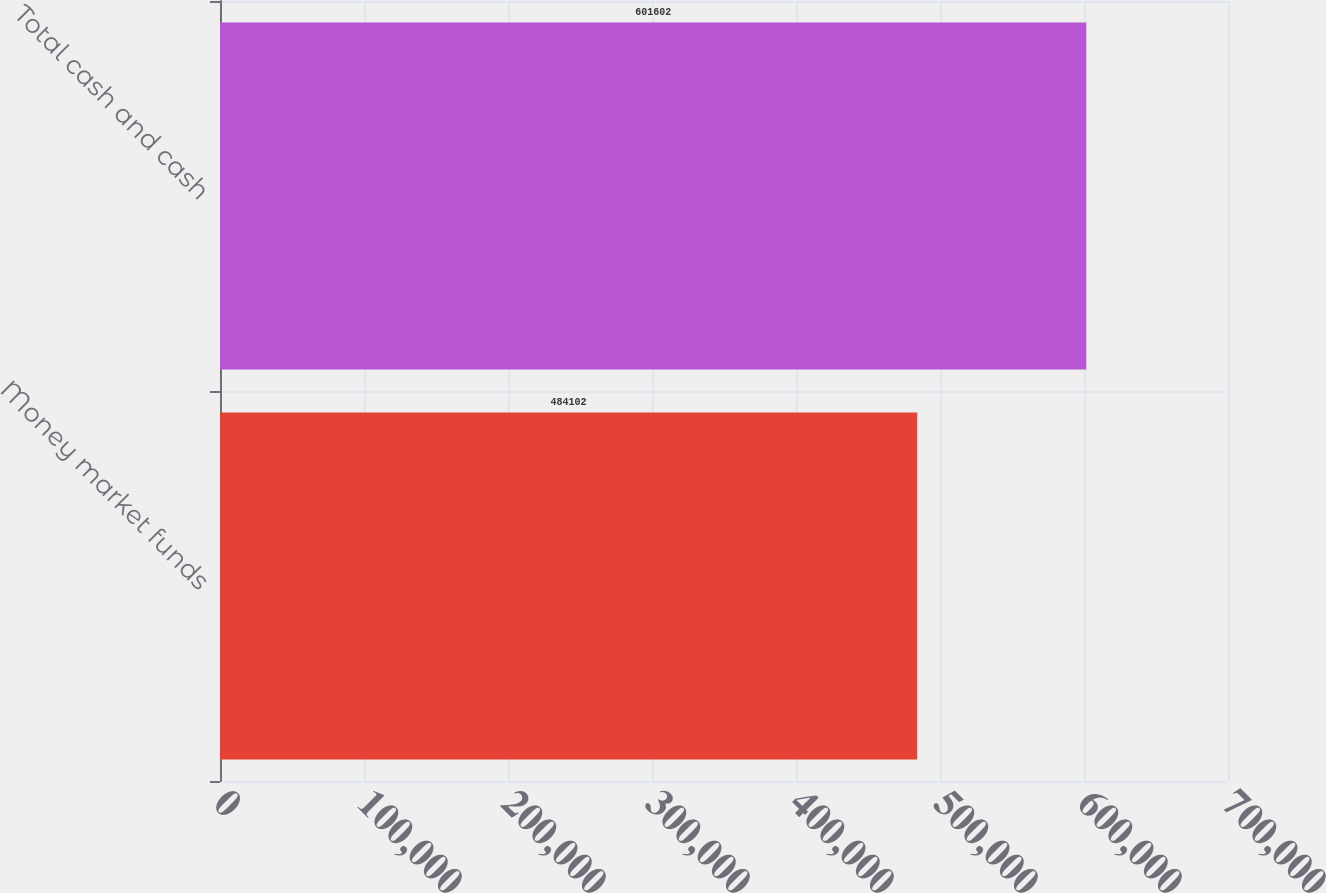Convert chart to OTSL. <chart><loc_0><loc_0><loc_500><loc_500><bar_chart><fcel>Money market funds<fcel>Total cash and cash<nl><fcel>484102<fcel>601602<nl></chart> 